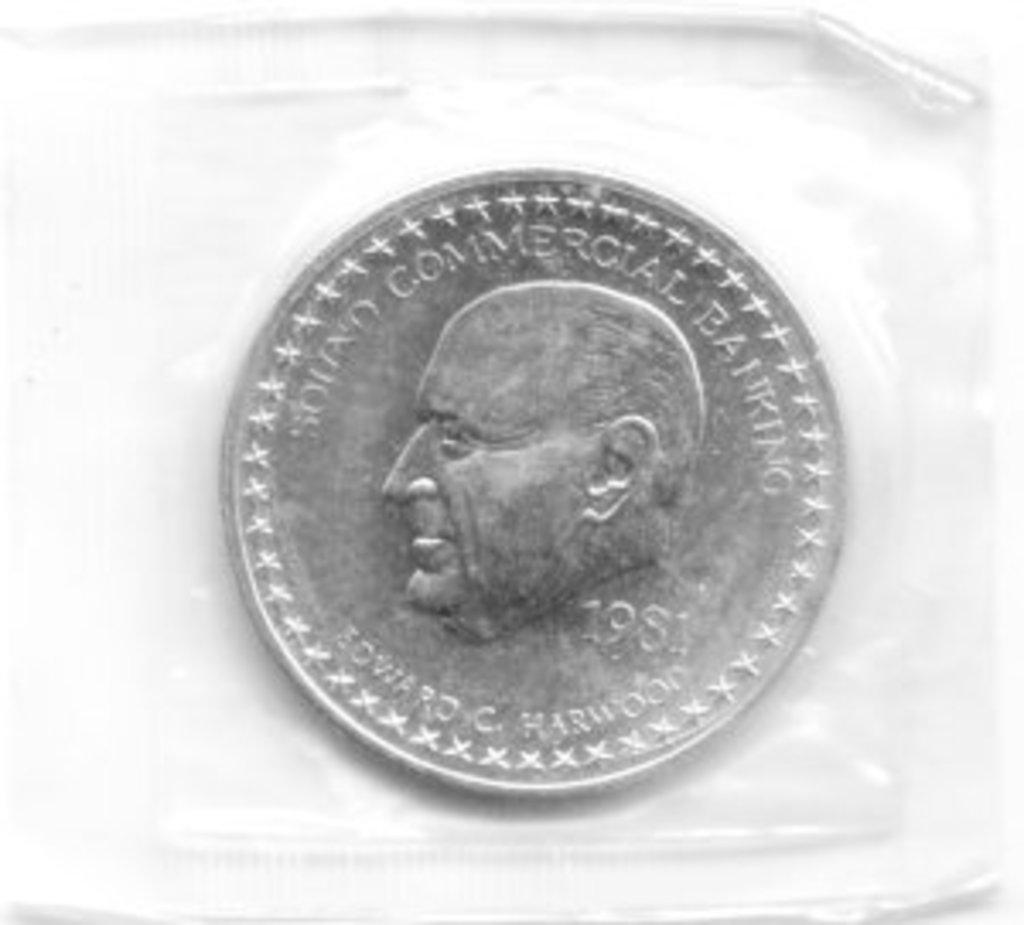What is the main object in the foreground of the image? There is a coin in the foreground of the image. What is depicted on the coin? The coin has a model of a person's face printed on it. Are there any words or letters on the coin? Yes, there is text on the coin. What color is the background of the image? The background of the image is white. How many pickles are visible in the image? There are no pickles present in the image. What are the girls doing in the image? There are no girls present in the image. How many cows can be seen in the image? There are no cows present in the image. 